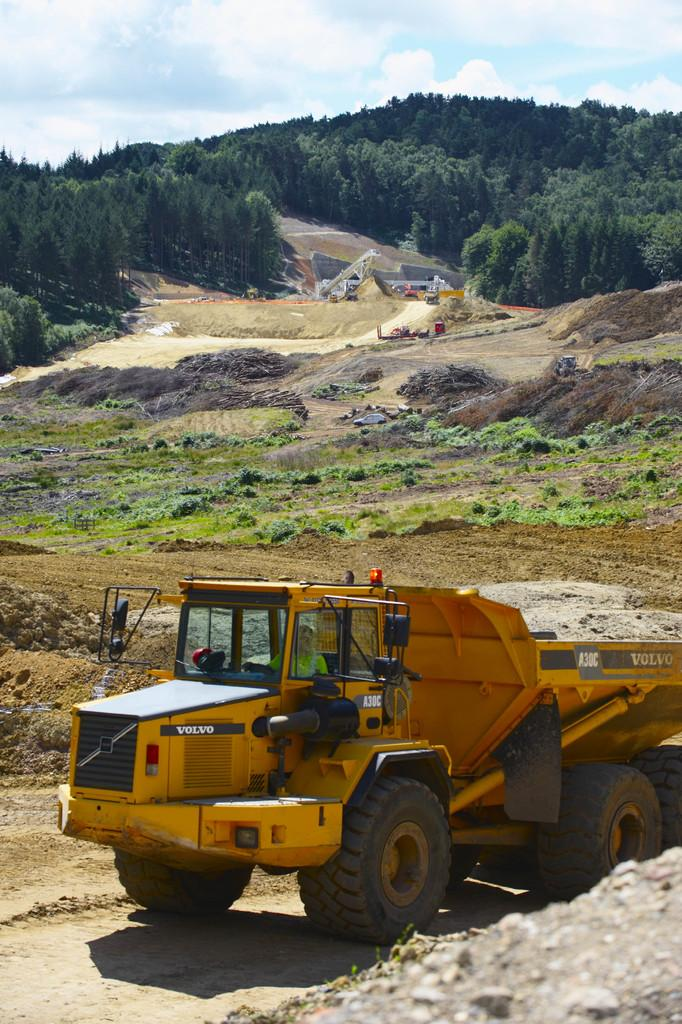What is located at the bottom of the image? There is a truck at the bottom of the image. What can be seen in the background of the image? There are trees and the sky visible in the background of the image. What type of vegetation is in the center of the image? There is grass in the center of the image. What type of lamp is hanging from the tree in the image? There is no lamp present in the image; it features a truck, trees, grass, and the sky. 